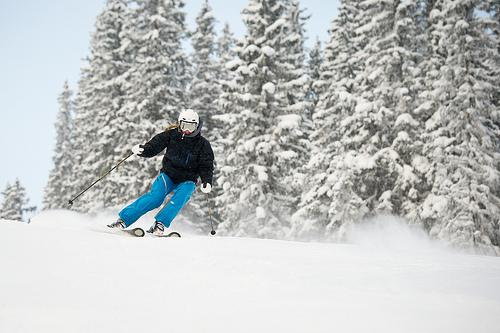Question: what is the person doing?
Choices:
A. Snowboarding.
B. Sledding.
C. Skiing.
D. Walking.
Answer with the letter. Answer: C Question: who are they with?
Choices:
A. Each other.
B. Family.
C. No one.
D. Friends.
Answer with the letter. Answer: C Question: what is on the trees?
Choices:
A. Ice.
B. Frost.
C. Snow.
D. Leaves.
Answer with the letter. Answer: C Question: what is on the skier's head?
Choices:
A. Goggles.
B. Hat.
C. A helmet.
D. Earmuffs.
Answer with the letter. Answer: C Question: where are they skiing?
Choices:
A. Down a hill.
B. Ski resort.
C. Mountain.
D. Colorado.
Answer with the letter. Answer: A Question: what color snow pants are they wearing?
Choices:
A. Blue.
B. White.
C. Black.
D. Yellow.
Answer with the letter. Answer: A 